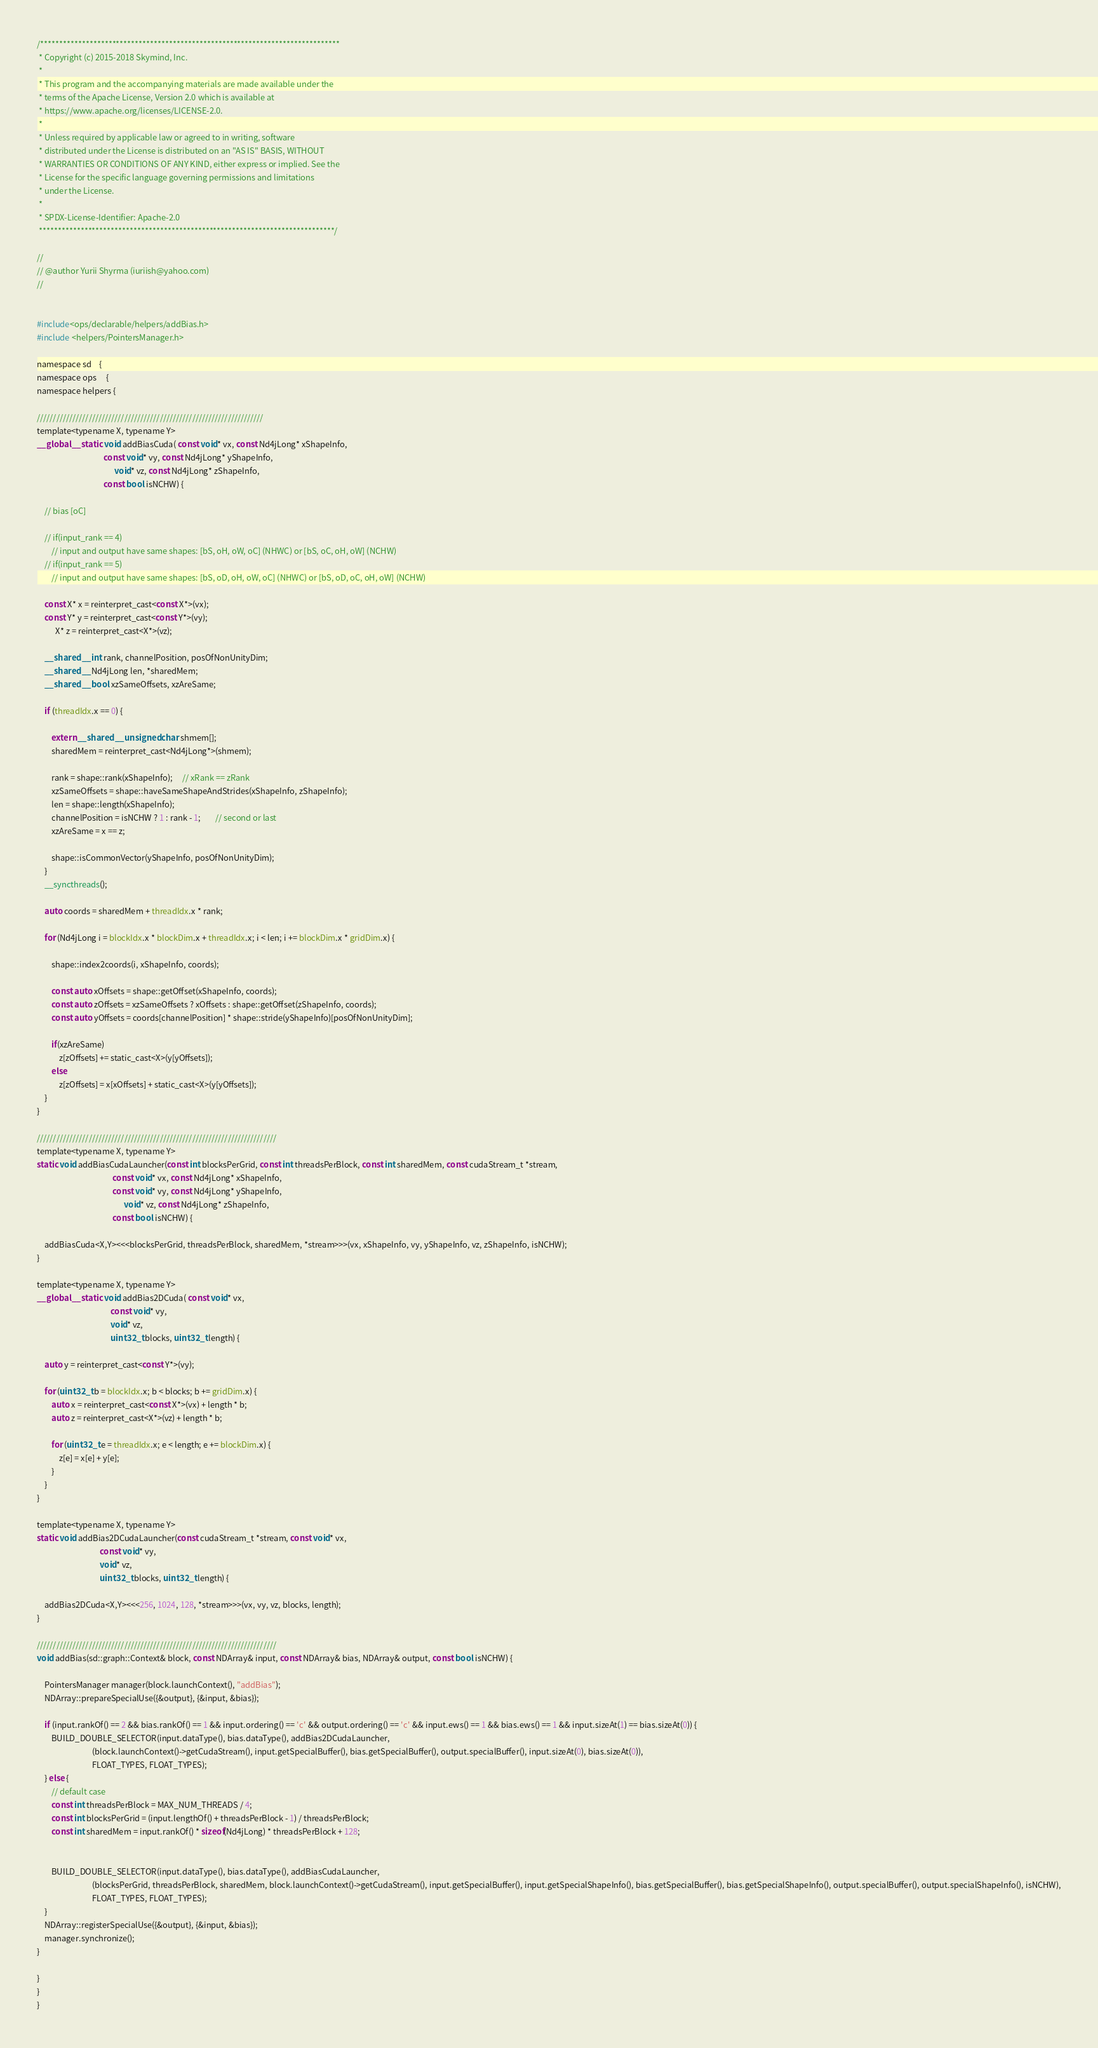<code> <loc_0><loc_0><loc_500><loc_500><_Cuda_>/*******************************************************************************
 * Copyright (c) 2015-2018 Skymind, Inc.
 *
 * This program and the accompanying materials are made available under the
 * terms of the Apache License, Version 2.0 which is available at
 * https://www.apache.org/licenses/LICENSE-2.0.
 *
 * Unless required by applicable law or agreed to in writing, software
 * distributed under the License is distributed on an "AS IS" BASIS, WITHOUT
 * WARRANTIES OR CONDITIONS OF ANY KIND, either express or implied. See the
 * License for the specific language governing permissions and limitations
 * under the License.
 *
 * SPDX-License-Identifier: Apache-2.0
 ******************************************************************************/

//
// @author Yurii Shyrma (iuriish@yahoo.com)
//


#include<ops/declarable/helpers/addBias.h>
#include <helpers/PointersManager.h>

namespace sd    {
namespace ops     {
namespace helpers {

//////////////////////////////////////////////////////////////////////
template<typename X, typename Y>
__global__ static void addBiasCuda( const void* vx, const Nd4jLong* xShapeInfo,
                                    const void* vy, const Nd4jLong* yShapeInfo,
                                          void* vz, const Nd4jLong* zShapeInfo,
                                    const bool isNCHW) {

    // bias [oC]

    // if(input_rank == 4)
        // input and output have same shapes: [bS, oH, oW, oC] (NHWC) or [bS, oC, oH, oW] (NCHW)
    // if(input_rank == 5)
        // input and output have same shapes: [bS, oD, oH, oW, oC] (NHWC) or [bS, oD, oC, oH, oW] (NCHW)

    const X* x = reinterpret_cast<const X*>(vx);
    const Y* y = reinterpret_cast<const Y*>(vy);
          X* z = reinterpret_cast<X*>(vz);

    __shared__ int rank, channelPosition, posOfNonUnityDim;
    __shared__ Nd4jLong len, *sharedMem;
    __shared__ bool xzSameOffsets, xzAreSame;

    if (threadIdx.x == 0) {

        extern __shared__ unsigned char shmem[];
        sharedMem = reinterpret_cast<Nd4jLong*>(shmem);

        rank = shape::rank(xShapeInfo);     // xRank == zRank
        xzSameOffsets = shape::haveSameShapeAndStrides(xShapeInfo, zShapeInfo);
        len = shape::length(xShapeInfo);
        channelPosition = isNCHW ? 1 : rank - 1;        // second or last
        xzAreSame = x == z;

        shape::isCommonVector(yShapeInfo, posOfNonUnityDim);
    }
    __syncthreads();

    auto coords = sharedMem + threadIdx.x * rank;

    for (Nd4jLong i = blockIdx.x * blockDim.x + threadIdx.x; i < len; i += blockDim.x * gridDim.x) {

        shape::index2coords(i, xShapeInfo, coords);

        const auto xOffsets = shape::getOffset(xShapeInfo, coords);
        const auto zOffsets = xzSameOffsets ? xOffsets : shape::getOffset(zShapeInfo, coords);
        const auto yOffsets = coords[channelPosition] * shape::stride(yShapeInfo)[posOfNonUnityDim];

        if(xzAreSame)
            z[zOffsets] += static_cast<X>(y[yOffsets]);
        else
            z[zOffsets] = x[xOffsets] + static_cast<X>(y[yOffsets]);
    }
}

//////////////////////////////////////////////////////////////////////////
template<typename X, typename Y>
static void addBiasCudaLauncher(const int blocksPerGrid, const int threadsPerBlock, const int sharedMem, const cudaStream_t *stream,
                                         const void* vx, const Nd4jLong* xShapeInfo,
                                         const void* vy, const Nd4jLong* yShapeInfo,
                                               void* vz, const Nd4jLong* zShapeInfo,
                                         const bool isNCHW) {

    addBiasCuda<X,Y><<<blocksPerGrid, threadsPerBlock, sharedMem, *stream>>>(vx, xShapeInfo, vy, yShapeInfo, vz, zShapeInfo, isNCHW);
}

template<typename X, typename Y>
__global__ static void addBias2DCuda( const void* vx,
                                        const void* vy,
                                        void* vz,
                                        uint32_t blocks, uint32_t length) {

    auto y = reinterpret_cast<const Y*>(vy);

    for (uint32_t b = blockIdx.x; b < blocks; b += gridDim.x) {
        auto x = reinterpret_cast<const X*>(vx) + length * b;
        auto z = reinterpret_cast<X*>(vz) + length * b;

        for (uint32_t e = threadIdx.x; e < length; e += blockDim.x) {
            z[e] = x[e] + y[e];
        }
    }
}

template<typename X, typename Y>
static void addBias2DCudaLauncher(const cudaStream_t *stream, const void* vx,
                                  const void* vy,
                                  void* vz,
                                  uint32_t blocks, uint32_t length) {

    addBias2DCuda<X,Y><<<256, 1024, 128, *stream>>>(vx, vy, vz, blocks, length);
}

//////////////////////////////////////////////////////////////////////////
void addBias(sd::graph::Context& block, const NDArray& input, const NDArray& bias, NDArray& output, const bool isNCHW) {

    PointersManager manager(block.launchContext(), "addBias");
    NDArray::prepareSpecialUse({&output}, {&input, &bias});

    if (input.rankOf() == 2 && bias.rankOf() == 1 && input.ordering() == 'c' && output.ordering() == 'c' && input.ews() == 1 && bias.ews() == 1 && input.sizeAt(1) == bias.sizeAt(0)) {
        BUILD_DOUBLE_SELECTOR(input.dataType(), bias.dataType(), addBias2DCudaLauncher,
                              (block.launchContext()->getCudaStream(), input.getSpecialBuffer(), bias.getSpecialBuffer(), output.specialBuffer(), input.sizeAt(0), bias.sizeAt(0)),
                              FLOAT_TYPES, FLOAT_TYPES);
    } else {
        // default case
        const int threadsPerBlock = MAX_NUM_THREADS / 4;
        const int blocksPerGrid = (input.lengthOf() + threadsPerBlock - 1) / threadsPerBlock;
        const int sharedMem = input.rankOf() * sizeof(Nd4jLong) * threadsPerBlock + 128;


        BUILD_DOUBLE_SELECTOR(input.dataType(), bias.dataType(), addBiasCudaLauncher,
                              (blocksPerGrid, threadsPerBlock, sharedMem, block.launchContext()->getCudaStream(), input.getSpecialBuffer(), input.getSpecialShapeInfo(), bias.getSpecialBuffer(), bias.getSpecialShapeInfo(), output.specialBuffer(), output.specialShapeInfo(), isNCHW),
                              FLOAT_TYPES, FLOAT_TYPES);
    }
    NDArray::registerSpecialUse({&output}, {&input, &bias});
    manager.synchronize();
}

}
}
}</code> 